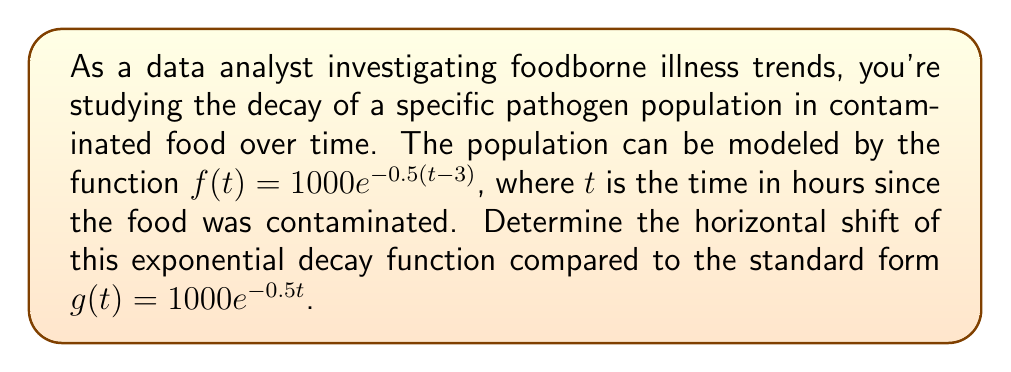Give your solution to this math problem. To determine the horizontal shift of the given exponential decay function, we need to compare it to the standard form of an exponential function.

1. The given function is:
   $f(t) = 1000e^{-0.5(t-3)}$

2. The standard form of an exponential function is:
   $g(t) = ab^{t}$, where $a$ is the initial value and $b$ is the base

3. In our case, the standard form would be:
   $g(t) = 1000e^{-0.5t}$

4. To find the horizontal shift, we need to rewrite $f(t)$ in a form similar to $g(t)$:
   $f(t) = 1000e^{-0.5(t-3)}$
   $f(t) = 1000e^{-0.5t+1.5}$
   $f(t) = 1000e^{1.5} \cdot e^{-0.5t}$

5. Comparing this to $g(t) = 1000e^{-0.5t}$, we can see that $f(t)$ is a horizontally shifted version of $g(t)$.

6. The horizontal shift is determined by the constant inside the parentheses in the exponent of the original function. In this case, it's 3.

7. A positive value inside the parentheses indicates a shift to the right.

Therefore, the function $f(t)$ is shifted 3 units to the right compared to the standard form $g(t)$.
Answer: The horizontal shift is 3 units to the right. 